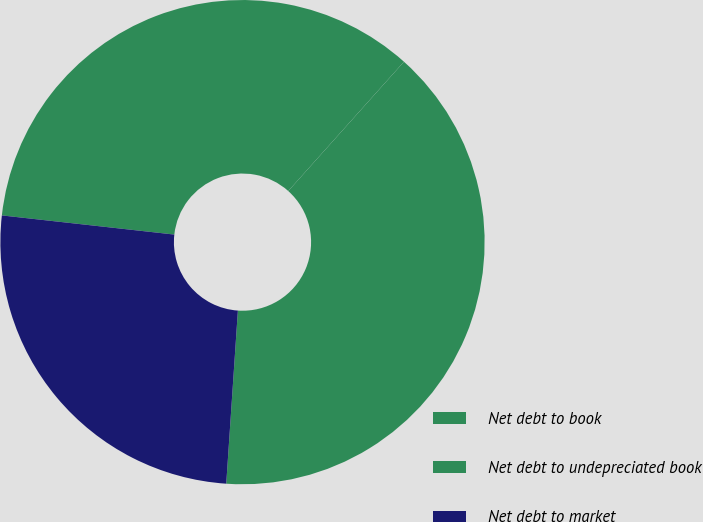Convert chart to OTSL. <chart><loc_0><loc_0><loc_500><loc_500><pie_chart><fcel>Net debt to book<fcel>Net debt to undepreciated book<fcel>Net debt to market<nl><fcel>39.45%<fcel>34.86%<fcel>25.69%<nl></chart> 